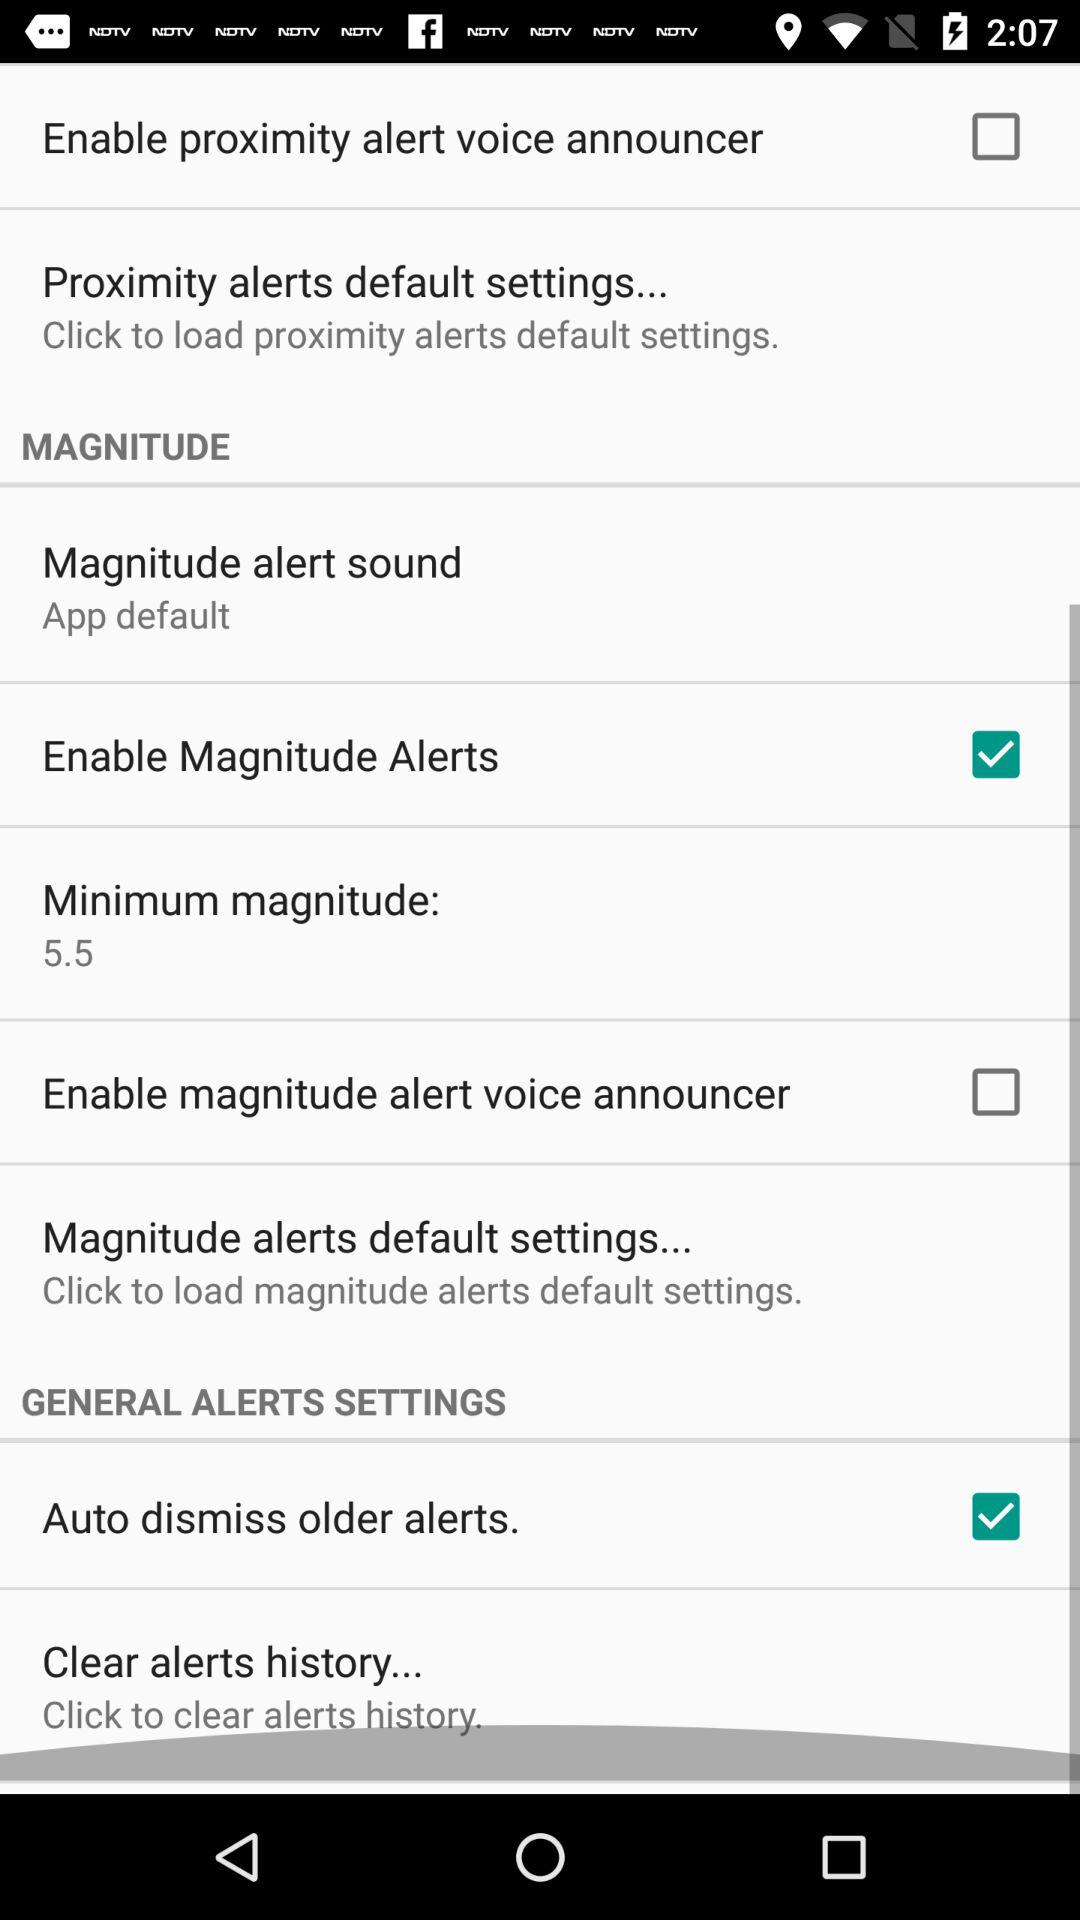What's the status of the auto dismiss older alerts? The status is "on". 